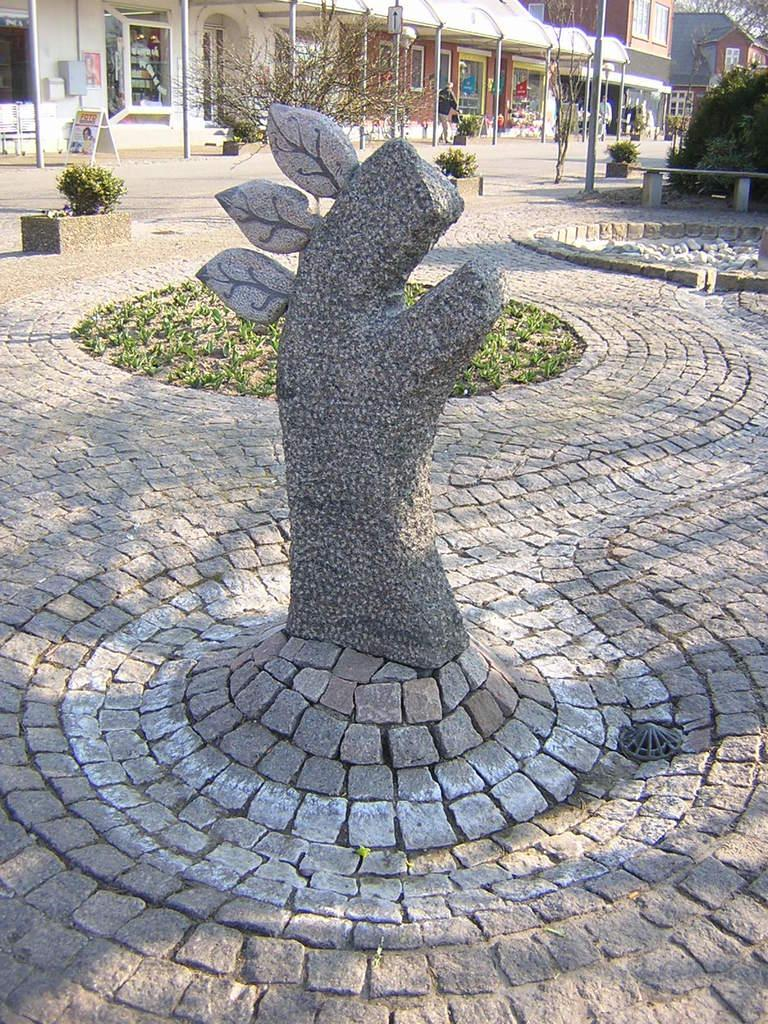What is the main subject in the image? There is a statue in the image. What other elements can be seen in the image besides the statue? There are plants and buildings visible in the image. Can you describe the presence of a person in the image? There is a person in the background of the image. What type of kite is being distributed by the arch in the image? There is no kite or arch present in the image. What kind of arch can be seen in the image? There is no arch present in the image. 